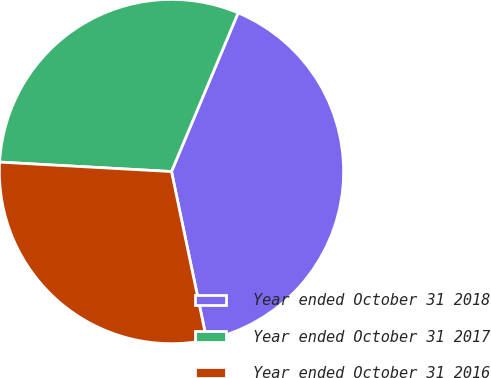Convert chart. <chart><loc_0><loc_0><loc_500><loc_500><pie_chart><fcel>Year ended October 31 2018<fcel>Year ended October 31 2017<fcel>Year ended October 31 2016<nl><fcel>40.39%<fcel>30.45%<fcel>29.15%<nl></chart> 